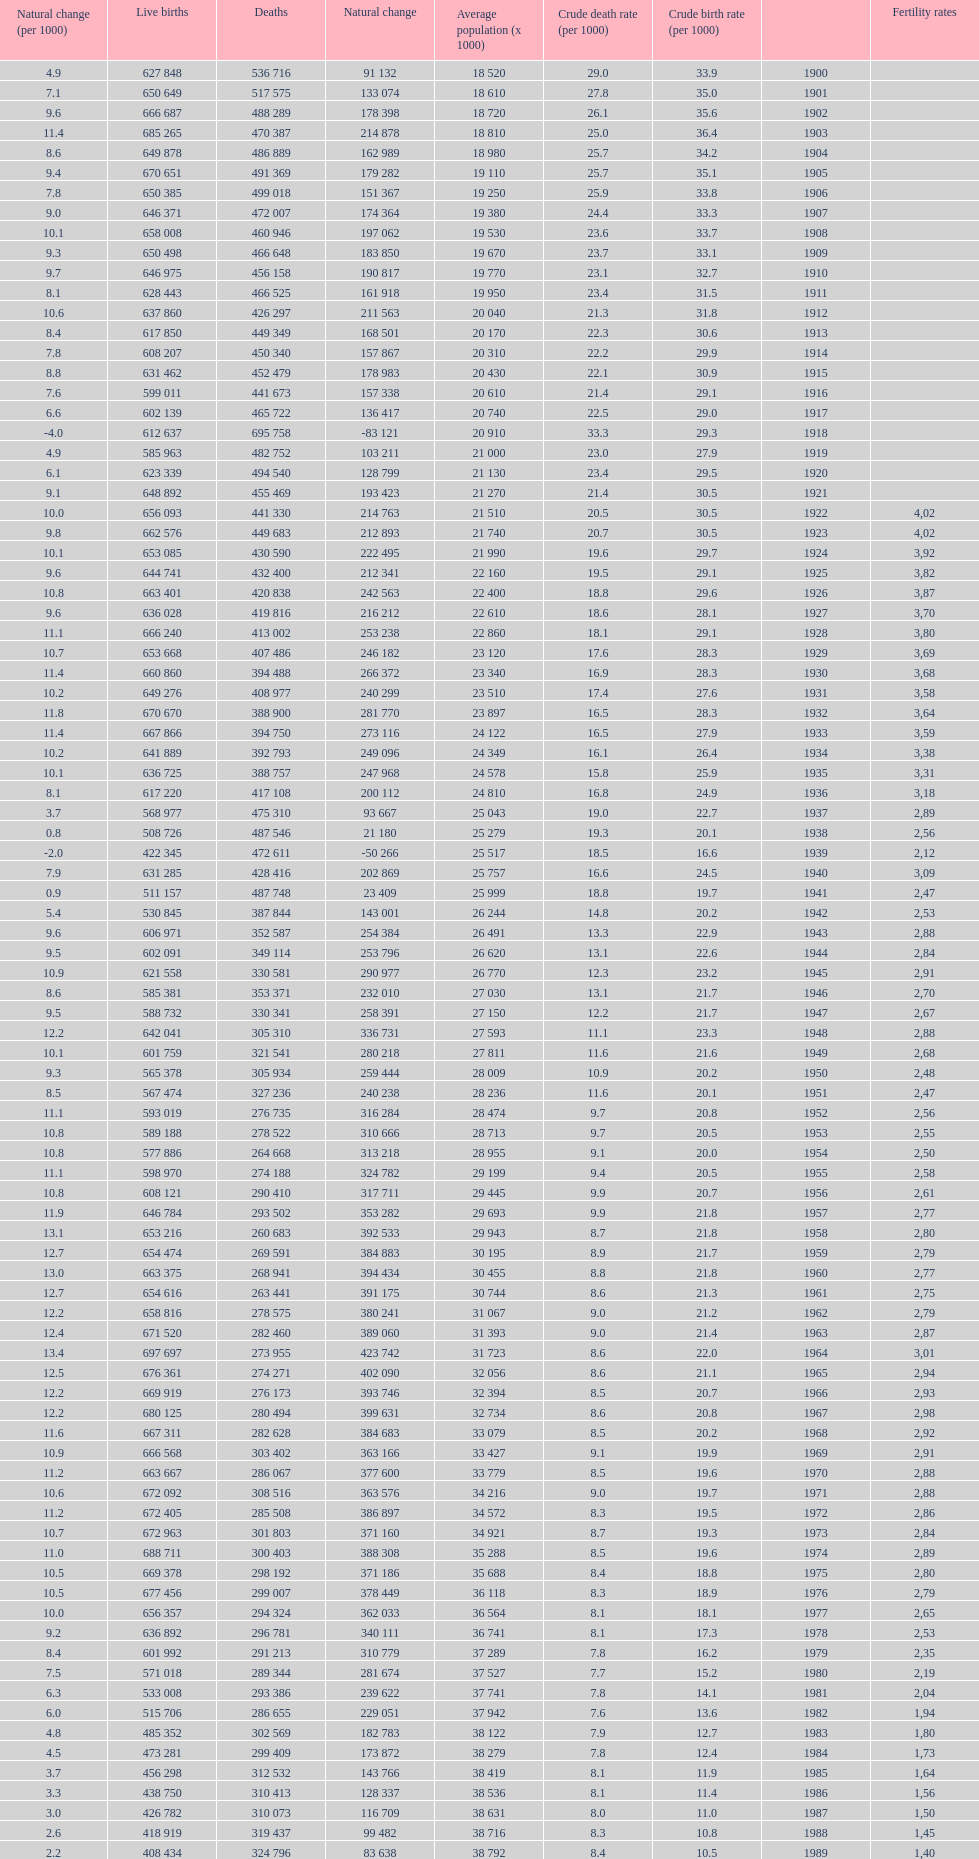Which year has a crude birth rate of 29.1 with a population of 22,860? 1928. 